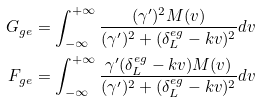Convert formula to latex. <formula><loc_0><loc_0><loc_500><loc_500>G _ { g e } & = \int _ { - \infty } ^ { + \infty } \frac { ( \gamma ^ { \prime } ) ^ { 2 } M ( v ) } { ( \gamma ^ { \prime } ) ^ { 2 } + ( \delta _ { L } ^ { e g } - k v ) ^ { 2 } } d v \\ F _ { g e } & = \int _ { - \infty } ^ { + \infty } \frac { \gamma ^ { \prime } ( \delta _ { L } ^ { e g } - k v ) M ( v ) } { ( \gamma ^ { \prime } ) ^ { 2 } + ( \delta _ { L } ^ { e g } - k v ) ^ { 2 } } d v</formula> 